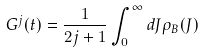Convert formula to latex. <formula><loc_0><loc_0><loc_500><loc_500>G ^ { j } ( t ) = \frac { 1 } { 2 j + 1 } \int _ { 0 } ^ { \infty } d J \rho _ { B } ( J )</formula> 